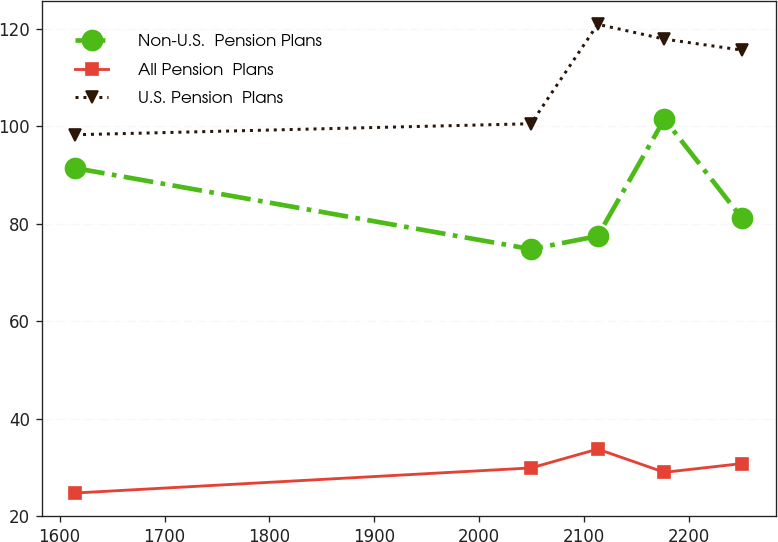<chart> <loc_0><loc_0><loc_500><loc_500><line_chart><ecel><fcel>Non-U.S.  Pension Plans<fcel>All Pension  Plans<fcel>U.S. Pension  Plans<nl><fcel>1614.72<fcel>91.38<fcel>24.77<fcel>98.22<nl><fcel>2049.32<fcel>74.77<fcel>29.91<fcel>100.48<nl><fcel>2112.91<fcel>77.44<fcel>33.77<fcel>120.87<nl><fcel>2176.5<fcel>101.43<fcel>29.01<fcel>117.83<nl><fcel>2250.64<fcel>81.05<fcel>30.81<fcel>115.57<nl></chart> 